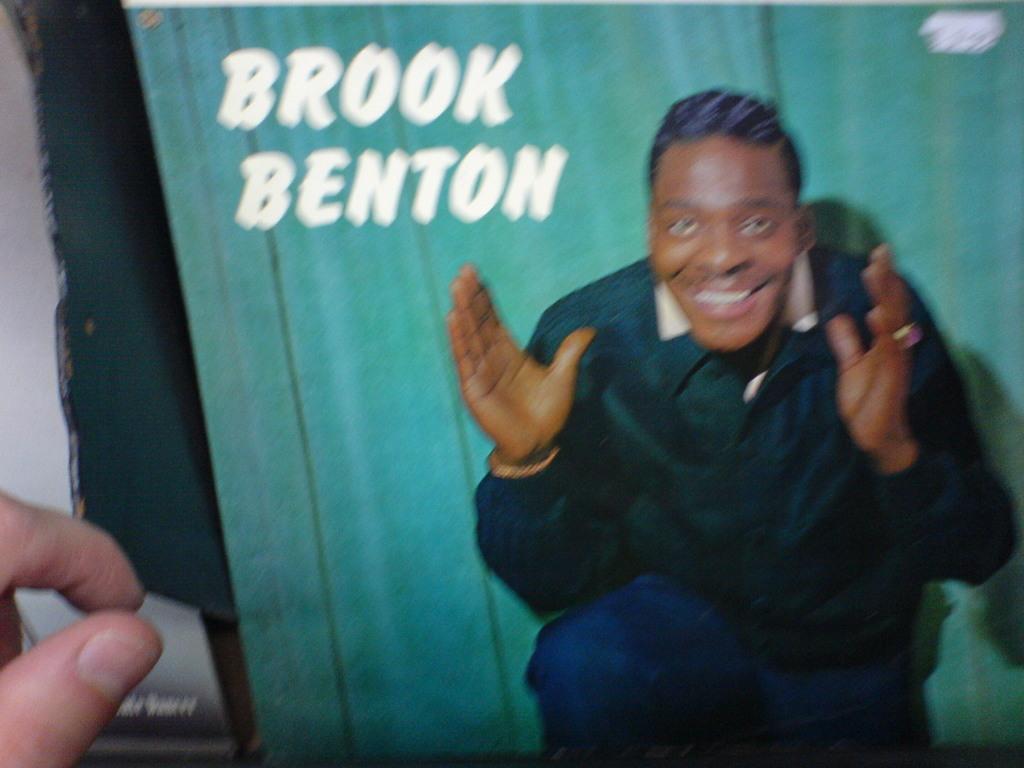How would you summarize this image in a sentence or two? This image consists of a poster. In which there is a man along with text. On the left, we can see the fingers of a person. 